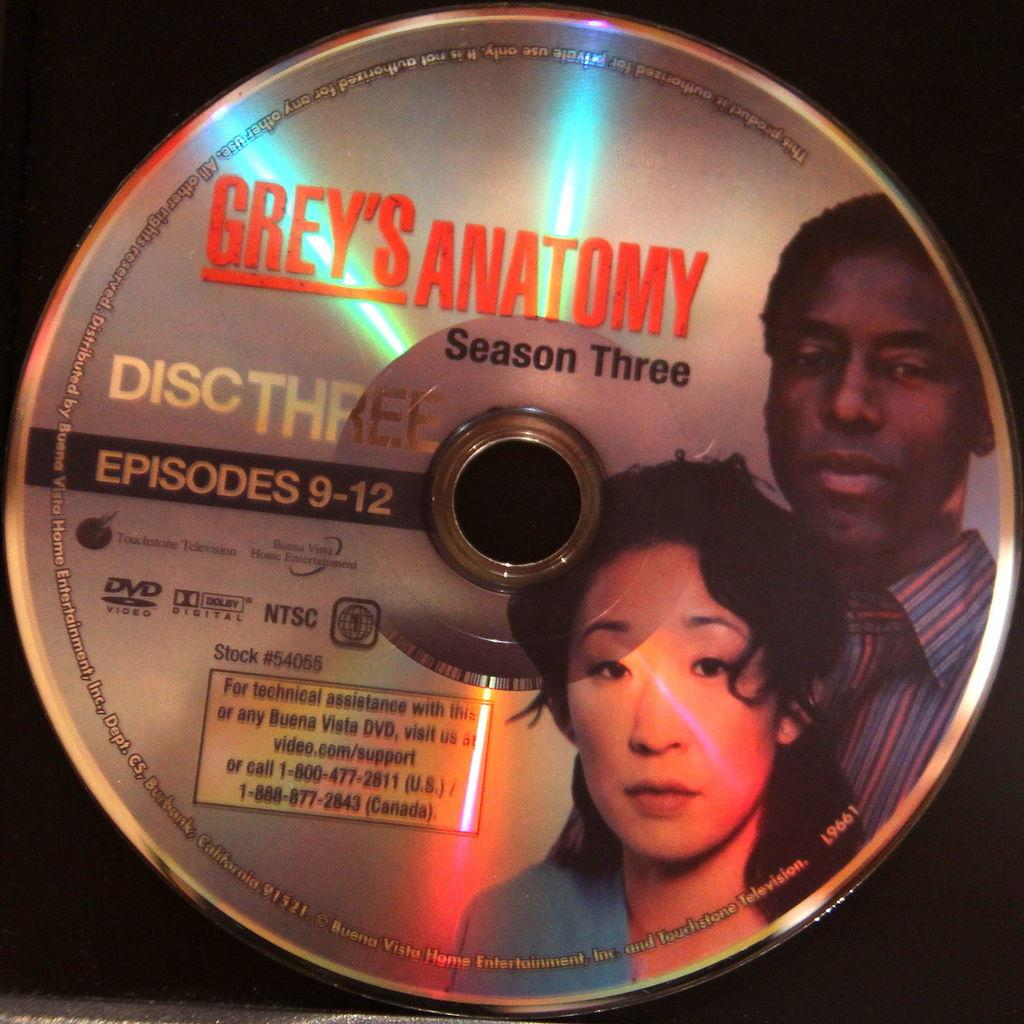What is the main object in the picture? There is a disk in the picture. What is depicted on the disk? The disk has an image of a man and a woman. What is written on the disk? The name "Grey's Anatomy" is written on the disk. What type of shock can be seen coming from the disk in the image? There is no shock present in the image; it features a disk with an image of a man and a woman and the name "Grey's Anatomy" written on it. 